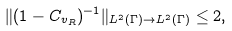Convert formula to latex. <formula><loc_0><loc_0><loc_500><loc_500>\| ( 1 - C _ { v _ { R } } ) ^ { - 1 } \| _ { L ^ { 2 } ( \Gamma ) \to L ^ { 2 } ( \Gamma ) } \leq 2 ,</formula> 